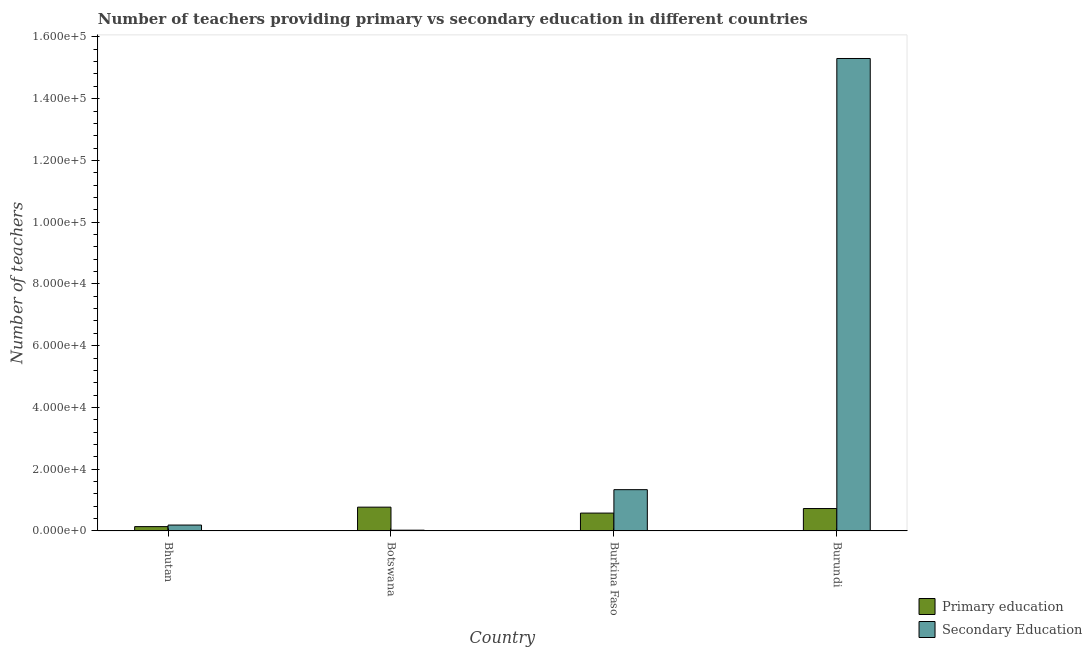How many different coloured bars are there?
Offer a very short reply. 2. How many groups of bars are there?
Your response must be concise. 4. Are the number of bars per tick equal to the number of legend labels?
Make the answer very short. Yes. Are the number of bars on each tick of the X-axis equal?
Keep it short and to the point. Yes. How many bars are there on the 4th tick from the left?
Offer a terse response. 2. How many bars are there on the 1st tick from the right?
Your response must be concise. 2. What is the label of the 2nd group of bars from the left?
Your answer should be very brief. Botswana. What is the number of primary teachers in Burundi?
Give a very brief answer. 7256. Across all countries, what is the maximum number of secondary teachers?
Your answer should be very brief. 1.53e+05. Across all countries, what is the minimum number of primary teachers?
Offer a terse response. 1398. In which country was the number of secondary teachers maximum?
Offer a very short reply. Burundi. In which country was the number of primary teachers minimum?
Offer a terse response. Bhutan. What is the total number of primary teachers in the graph?
Ensure brevity in your answer.  2.21e+04. What is the difference between the number of secondary teachers in Burkina Faso and that in Burundi?
Offer a very short reply. -1.40e+05. What is the difference between the number of secondary teachers in Burkina Faso and the number of primary teachers in Burundi?
Provide a succinct answer. 6114. What is the average number of primary teachers per country?
Give a very brief answer. 5534.5. What is the difference between the number of secondary teachers and number of primary teachers in Bhutan?
Keep it short and to the point. 510. What is the ratio of the number of primary teachers in Botswana to that in Burundi?
Your answer should be compact. 1.06. Is the number of secondary teachers in Botswana less than that in Burundi?
Your answer should be very brief. Yes. Is the difference between the number of secondary teachers in Bhutan and Botswana greater than the difference between the number of primary teachers in Bhutan and Botswana?
Provide a short and direct response. Yes. What is the difference between the highest and the second highest number of secondary teachers?
Keep it short and to the point. 1.40e+05. What is the difference between the highest and the lowest number of primary teachers?
Provide a succinct answer. 6306. In how many countries, is the number of secondary teachers greater than the average number of secondary teachers taken over all countries?
Give a very brief answer. 1. Is the sum of the number of secondary teachers in Bhutan and Burundi greater than the maximum number of primary teachers across all countries?
Keep it short and to the point. Yes. What does the 2nd bar from the left in Botswana represents?
Offer a terse response. Secondary Education. How many bars are there?
Make the answer very short. 8. Are all the bars in the graph horizontal?
Make the answer very short. No. How many countries are there in the graph?
Offer a very short reply. 4. What is the difference between two consecutive major ticks on the Y-axis?
Your answer should be compact. 2.00e+04. Are the values on the major ticks of Y-axis written in scientific E-notation?
Your answer should be very brief. Yes. Does the graph contain grids?
Your answer should be compact. No. How many legend labels are there?
Give a very brief answer. 2. What is the title of the graph?
Keep it short and to the point. Number of teachers providing primary vs secondary education in different countries. What is the label or title of the Y-axis?
Offer a terse response. Number of teachers. What is the Number of teachers in Primary education in Bhutan?
Keep it short and to the point. 1398. What is the Number of teachers of Secondary Education in Bhutan?
Offer a terse response. 1908. What is the Number of teachers of Primary education in Botswana?
Ensure brevity in your answer.  7704. What is the Number of teachers in Secondary Education in Botswana?
Ensure brevity in your answer.  247. What is the Number of teachers in Primary education in Burkina Faso?
Your response must be concise. 5780. What is the Number of teachers in Secondary Education in Burkina Faso?
Make the answer very short. 1.34e+04. What is the Number of teachers in Primary education in Burundi?
Keep it short and to the point. 7256. What is the Number of teachers of Secondary Education in Burundi?
Your answer should be very brief. 1.53e+05. Across all countries, what is the maximum Number of teachers in Primary education?
Give a very brief answer. 7704. Across all countries, what is the maximum Number of teachers of Secondary Education?
Offer a very short reply. 1.53e+05. Across all countries, what is the minimum Number of teachers of Primary education?
Your response must be concise. 1398. Across all countries, what is the minimum Number of teachers in Secondary Education?
Give a very brief answer. 247. What is the total Number of teachers in Primary education in the graph?
Ensure brevity in your answer.  2.21e+04. What is the total Number of teachers of Secondary Education in the graph?
Give a very brief answer. 1.69e+05. What is the difference between the Number of teachers of Primary education in Bhutan and that in Botswana?
Make the answer very short. -6306. What is the difference between the Number of teachers of Secondary Education in Bhutan and that in Botswana?
Your answer should be very brief. 1661. What is the difference between the Number of teachers in Primary education in Bhutan and that in Burkina Faso?
Give a very brief answer. -4382. What is the difference between the Number of teachers of Secondary Education in Bhutan and that in Burkina Faso?
Give a very brief answer. -1.15e+04. What is the difference between the Number of teachers of Primary education in Bhutan and that in Burundi?
Your answer should be compact. -5858. What is the difference between the Number of teachers in Secondary Education in Bhutan and that in Burundi?
Your response must be concise. -1.51e+05. What is the difference between the Number of teachers of Primary education in Botswana and that in Burkina Faso?
Your answer should be compact. 1924. What is the difference between the Number of teachers in Secondary Education in Botswana and that in Burkina Faso?
Offer a terse response. -1.31e+04. What is the difference between the Number of teachers in Primary education in Botswana and that in Burundi?
Offer a terse response. 448. What is the difference between the Number of teachers of Secondary Education in Botswana and that in Burundi?
Make the answer very short. -1.53e+05. What is the difference between the Number of teachers of Primary education in Burkina Faso and that in Burundi?
Make the answer very short. -1476. What is the difference between the Number of teachers in Secondary Education in Burkina Faso and that in Burundi?
Provide a short and direct response. -1.40e+05. What is the difference between the Number of teachers of Primary education in Bhutan and the Number of teachers of Secondary Education in Botswana?
Offer a terse response. 1151. What is the difference between the Number of teachers of Primary education in Bhutan and the Number of teachers of Secondary Education in Burkina Faso?
Give a very brief answer. -1.20e+04. What is the difference between the Number of teachers in Primary education in Bhutan and the Number of teachers in Secondary Education in Burundi?
Your answer should be compact. -1.52e+05. What is the difference between the Number of teachers in Primary education in Botswana and the Number of teachers in Secondary Education in Burkina Faso?
Ensure brevity in your answer.  -5666. What is the difference between the Number of teachers in Primary education in Botswana and the Number of teachers in Secondary Education in Burundi?
Your response must be concise. -1.45e+05. What is the difference between the Number of teachers of Primary education in Burkina Faso and the Number of teachers of Secondary Education in Burundi?
Provide a short and direct response. -1.47e+05. What is the average Number of teachers of Primary education per country?
Your answer should be very brief. 5534.5. What is the average Number of teachers of Secondary Education per country?
Ensure brevity in your answer.  4.21e+04. What is the difference between the Number of teachers of Primary education and Number of teachers of Secondary Education in Bhutan?
Offer a very short reply. -510. What is the difference between the Number of teachers in Primary education and Number of teachers in Secondary Education in Botswana?
Your response must be concise. 7457. What is the difference between the Number of teachers of Primary education and Number of teachers of Secondary Education in Burkina Faso?
Provide a succinct answer. -7590. What is the difference between the Number of teachers in Primary education and Number of teachers in Secondary Education in Burundi?
Your answer should be compact. -1.46e+05. What is the ratio of the Number of teachers in Primary education in Bhutan to that in Botswana?
Give a very brief answer. 0.18. What is the ratio of the Number of teachers in Secondary Education in Bhutan to that in Botswana?
Keep it short and to the point. 7.72. What is the ratio of the Number of teachers in Primary education in Bhutan to that in Burkina Faso?
Your response must be concise. 0.24. What is the ratio of the Number of teachers in Secondary Education in Bhutan to that in Burkina Faso?
Offer a terse response. 0.14. What is the ratio of the Number of teachers in Primary education in Bhutan to that in Burundi?
Give a very brief answer. 0.19. What is the ratio of the Number of teachers of Secondary Education in Bhutan to that in Burundi?
Your answer should be very brief. 0.01. What is the ratio of the Number of teachers of Primary education in Botswana to that in Burkina Faso?
Your answer should be compact. 1.33. What is the ratio of the Number of teachers in Secondary Education in Botswana to that in Burkina Faso?
Make the answer very short. 0.02. What is the ratio of the Number of teachers of Primary education in Botswana to that in Burundi?
Give a very brief answer. 1.06. What is the ratio of the Number of teachers in Secondary Education in Botswana to that in Burundi?
Ensure brevity in your answer.  0. What is the ratio of the Number of teachers of Primary education in Burkina Faso to that in Burundi?
Offer a very short reply. 0.8. What is the ratio of the Number of teachers in Secondary Education in Burkina Faso to that in Burundi?
Offer a very short reply. 0.09. What is the difference between the highest and the second highest Number of teachers of Primary education?
Make the answer very short. 448. What is the difference between the highest and the second highest Number of teachers in Secondary Education?
Your answer should be very brief. 1.40e+05. What is the difference between the highest and the lowest Number of teachers of Primary education?
Keep it short and to the point. 6306. What is the difference between the highest and the lowest Number of teachers of Secondary Education?
Provide a short and direct response. 1.53e+05. 